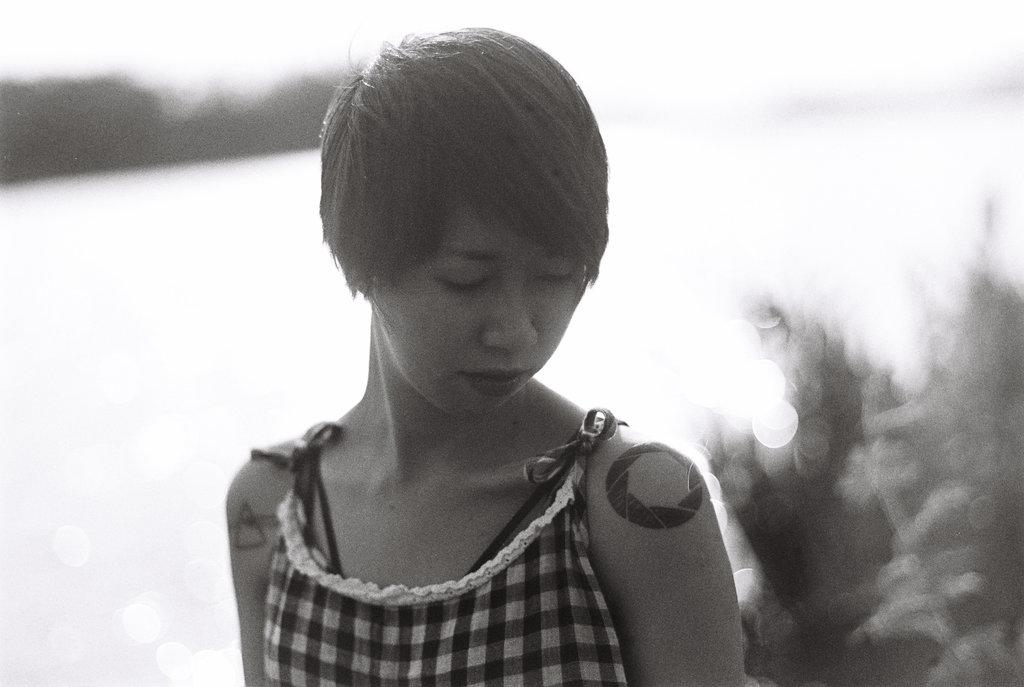What is the color scheme of the image? The image is black and white. Who is present in the image? There is a woman in the image. Can you describe the background of the image? The background is blurry. What feature can be observed on the woman's hands? The woman has a tattoo on her hands. What type of peace symbol can be seen on the woman's shirt in the image? There is no peace symbol or shirt visible in the image; it is a black and white image of a woman with a blurry background and a tattoo on her hands. 